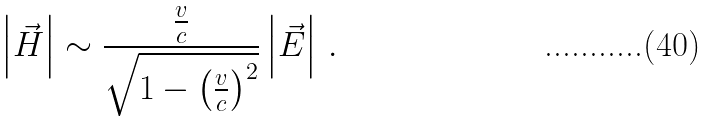<formula> <loc_0><loc_0><loc_500><loc_500>\left | \vec { H } \right | \sim \frac { \frac { v } { c } } { \sqrt { 1 - \left ( \frac { v } { c } \right ) ^ { 2 } } } \left | \vec { E } \right | \, .</formula> 